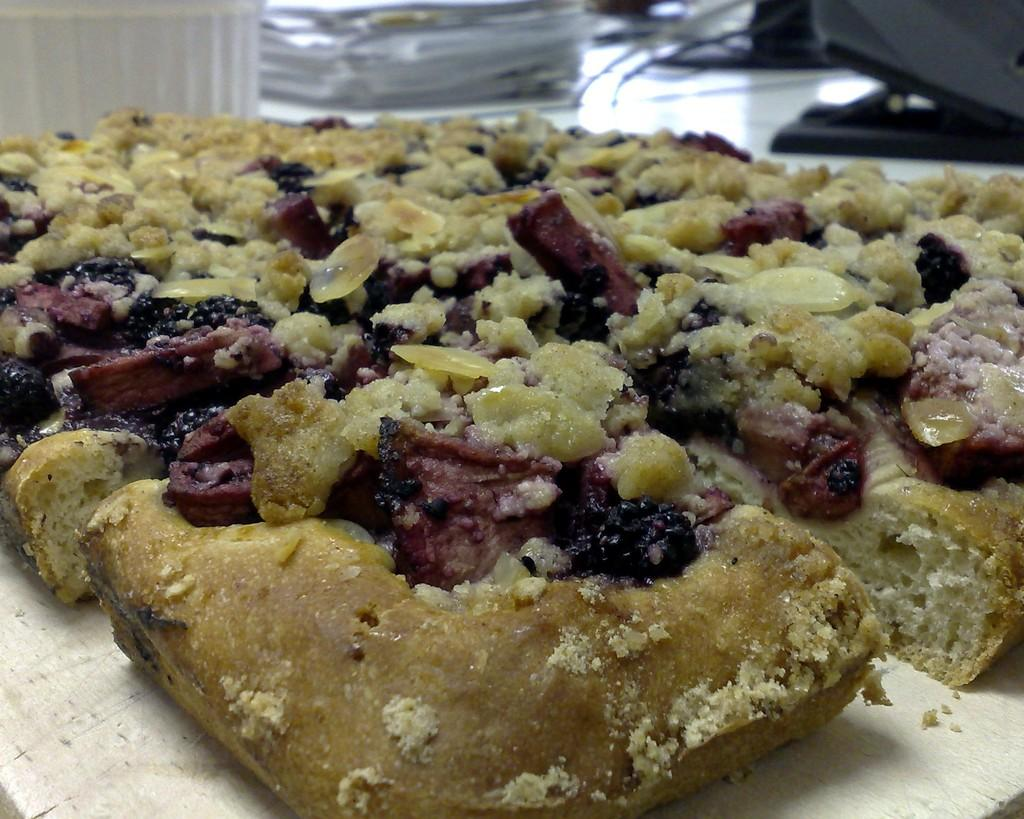What is the main subject of the image? There is a pastry in the image. Where is the pastry located in the image? The pastry is in the center of the image. What type of sweater is the pastry wearing in the image? There is no sweater present in the image, as the subject is a pastry and not a person. 